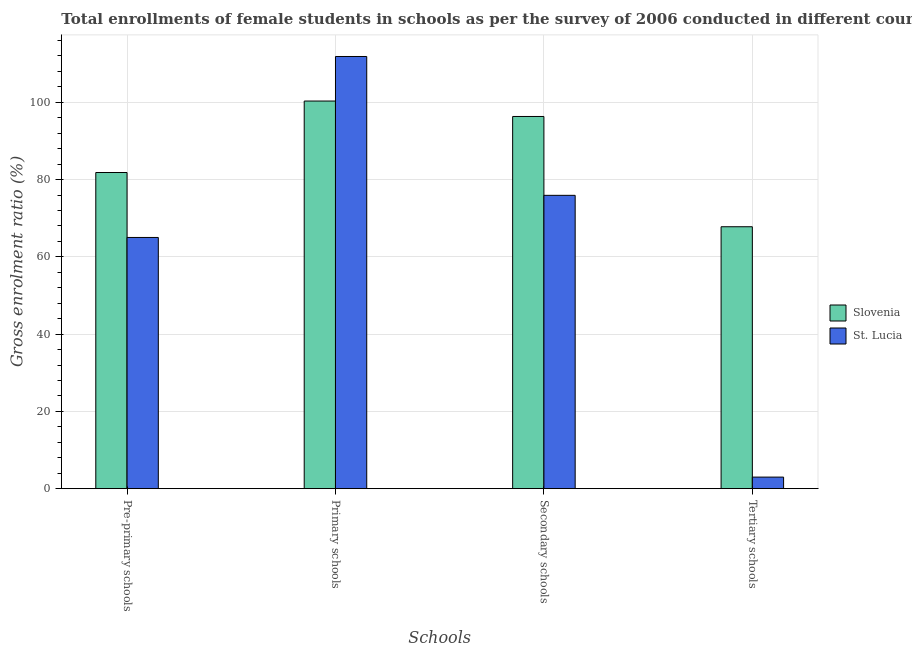How many different coloured bars are there?
Provide a succinct answer. 2. What is the label of the 4th group of bars from the left?
Keep it short and to the point. Tertiary schools. What is the gross enrolment ratio(female) in primary schools in St. Lucia?
Provide a succinct answer. 111.87. Across all countries, what is the maximum gross enrolment ratio(female) in tertiary schools?
Offer a terse response. 67.8. Across all countries, what is the minimum gross enrolment ratio(female) in secondary schools?
Your answer should be compact. 75.93. In which country was the gross enrolment ratio(female) in tertiary schools maximum?
Provide a short and direct response. Slovenia. In which country was the gross enrolment ratio(female) in tertiary schools minimum?
Provide a short and direct response. St. Lucia. What is the total gross enrolment ratio(female) in secondary schools in the graph?
Keep it short and to the point. 172.28. What is the difference between the gross enrolment ratio(female) in tertiary schools in Slovenia and that in St. Lucia?
Keep it short and to the point. 64.8. What is the difference between the gross enrolment ratio(female) in secondary schools in Slovenia and the gross enrolment ratio(female) in pre-primary schools in St. Lucia?
Offer a terse response. 31.32. What is the average gross enrolment ratio(female) in secondary schools per country?
Ensure brevity in your answer.  86.14. What is the difference between the gross enrolment ratio(female) in pre-primary schools and gross enrolment ratio(female) in primary schools in St. Lucia?
Give a very brief answer. -46.85. In how many countries, is the gross enrolment ratio(female) in tertiary schools greater than 48 %?
Your response must be concise. 1. What is the ratio of the gross enrolment ratio(female) in pre-primary schools in Slovenia to that in St. Lucia?
Offer a terse response. 1.26. Is the gross enrolment ratio(female) in tertiary schools in Slovenia less than that in St. Lucia?
Give a very brief answer. No. What is the difference between the highest and the second highest gross enrolment ratio(female) in primary schools?
Offer a very short reply. 11.53. What is the difference between the highest and the lowest gross enrolment ratio(female) in pre-primary schools?
Offer a very short reply. 16.82. Is the sum of the gross enrolment ratio(female) in secondary schools in St. Lucia and Slovenia greater than the maximum gross enrolment ratio(female) in primary schools across all countries?
Your answer should be very brief. Yes. Is it the case that in every country, the sum of the gross enrolment ratio(female) in pre-primary schools and gross enrolment ratio(female) in secondary schools is greater than the sum of gross enrolment ratio(female) in primary schools and gross enrolment ratio(female) in tertiary schools?
Give a very brief answer. Yes. What does the 2nd bar from the left in Primary schools represents?
Ensure brevity in your answer.  St. Lucia. What does the 1st bar from the right in Tertiary schools represents?
Your answer should be very brief. St. Lucia. Is it the case that in every country, the sum of the gross enrolment ratio(female) in pre-primary schools and gross enrolment ratio(female) in primary schools is greater than the gross enrolment ratio(female) in secondary schools?
Ensure brevity in your answer.  Yes. How many countries are there in the graph?
Make the answer very short. 2. Does the graph contain any zero values?
Offer a very short reply. No. Does the graph contain grids?
Provide a short and direct response. Yes. Where does the legend appear in the graph?
Your response must be concise. Center right. What is the title of the graph?
Provide a succinct answer. Total enrollments of female students in schools as per the survey of 2006 conducted in different countries. Does "Serbia" appear as one of the legend labels in the graph?
Keep it short and to the point. No. What is the label or title of the X-axis?
Your response must be concise. Schools. What is the label or title of the Y-axis?
Give a very brief answer. Gross enrolment ratio (%). What is the Gross enrolment ratio (%) of Slovenia in Pre-primary schools?
Provide a short and direct response. 81.84. What is the Gross enrolment ratio (%) of St. Lucia in Pre-primary schools?
Offer a terse response. 65.03. What is the Gross enrolment ratio (%) of Slovenia in Primary schools?
Your answer should be very brief. 100.34. What is the Gross enrolment ratio (%) in St. Lucia in Primary schools?
Keep it short and to the point. 111.87. What is the Gross enrolment ratio (%) of Slovenia in Secondary schools?
Provide a succinct answer. 96.35. What is the Gross enrolment ratio (%) in St. Lucia in Secondary schools?
Provide a succinct answer. 75.93. What is the Gross enrolment ratio (%) in Slovenia in Tertiary schools?
Give a very brief answer. 67.8. What is the Gross enrolment ratio (%) in St. Lucia in Tertiary schools?
Provide a short and direct response. 3. Across all Schools, what is the maximum Gross enrolment ratio (%) of Slovenia?
Give a very brief answer. 100.34. Across all Schools, what is the maximum Gross enrolment ratio (%) of St. Lucia?
Offer a very short reply. 111.87. Across all Schools, what is the minimum Gross enrolment ratio (%) in Slovenia?
Offer a terse response. 67.8. Across all Schools, what is the minimum Gross enrolment ratio (%) of St. Lucia?
Your answer should be compact. 3. What is the total Gross enrolment ratio (%) in Slovenia in the graph?
Keep it short and to the point. 346.33. What is the total Gross enrolment ratio (%) in St. Lucia in the graph?
Provide a short and direct response. 255.83. What is the difference between the Gross enrolment ratio (%) of Slovenia in Pre-primary schools and that in Primary schools?
Make the answer very short. -18.5. What is the difference between the Gross enrolment ratio (%) in St. Lucia in Pre-primary schools and that in Primary schools?
Offer a terse response. -46.85. What is the difference between the Gross enrolment ratio (%) in Slovenia in Pre-primary schools and that in Secondary schools?
Your response must be concise. -14.51. What is the difference between the Gross enrolment ratio (%) in St. Lucia in Pre-primary schools and that in Secondary schools?
Give a very brief answer. -10.9. What is the difference between the Gross enrolment ratio (%) in Slovenia in Pre-primary schools and that in Tertiary schools?
Make the answer very short. 14.04. What is the difference between the Gross enrolment ratio (%) in St. Lucia in Pre-primary schools and that in Tertiary schools?
Offer a very short reply. 62.03. What is the difference between the Gross enrolment ratio (%) in Slovenia in Primary schools and that in Secondary schools?
Make the answer very short. 4. What is the difference between the Gross enrolment ratio (%) in St. Lucia in Primary schools and that in Secondary schools?
Make the answer very short. 35.94. What is the difference between the Gross enrolment ratio (%) of Slovenia in Primary schools and that in Tertiary schools?
Offer a terse response. 32.54. What is the difference between the Gross enrolment ratio (%) of St. Lucia in Primary schools and that in Tertiary schools?
Provide a short and direct response. 108.88. What is the difference between the Gross enrolment ratio (%) of Slovenia in Secondary schools and that in Tertiary schools?
Ensure brevity in your answer.  28.55. What is the difference between the Gross enrolment ratio (%) of St. Lucia in Secondary schools and that in Tertiary schools?
Give a very brief answer. 72.93. What is the difference between the Gross enrolment ratio (%) in Slovenia in Pre-primary schools and the Gross enrolment ratio (%) in St. Lucia in Primary schools?
Provide a short and direct response. -30.03. What is the difference between the Gross enrolment ratio (%) in Slovenia in Pre-primary schools and the Gross enrolment ratio (%) in St. Lucia in Secondary schools?
Your response must be concise. 5.91. What is the difference between the Gross enrolment ratio (%) of Slovenia in Pre-primary schools and the Gross enrolment ratio (%) of St. Lucia in Tertiary schools?
Provide a short and direct response. 78.84. What is the difference between the Gross enrolment ratio (%) of Slovenia in Primary schools and the Gross enrolment ratio (%) of St. Lucia in Secondary schools?
Give a very brief answer. 24.41. What is the difference between the Gross enrolment ratio (%) in Slovenia in Primary schools and the Gross enrolment ratio (%) in St. Lucia in Tertiary schools?
Give a very brief answer. 97.35. What is the difference between the Gross enrolment ratio (%) in Slovenia in Secondary schools and the Gross enrolment ratio (%) in St. Lucia in Tertiary schools?
Ensure brevity in your answer.  93.35. What is the average Gross enrolment ratio (%) in Slovenia per Schools?
Keep it short and to the point. 86.58. What is the average Gross enrolment ratio (%) in St. Lucia per Schools?
Provide a succinct answer. 63.96. What is the difference between the Gross enrolment ratio (%) of Slovenia and Gross enrolment ratio (%) of St. Lucia in Pre-primary schools?
Provide a succinct answer. 16.82. What is the difference between the Gross enrolment ratio (%) of Slovenia and Gross enrolment ratio (%) of St. Lucia in Primary schools?
Your answer should be compact. -11.53. What is the difference between the Gross enrolment ratio (%) of Slovenia and Gross enrolment ratio (%) of St. Lucia in Secondary schools?
Your response must be concise. 20.42. What is the difference between the Gross enrolment ratio (%) of Slovenia and Gross enrolment ratio (%) of St. Lucia in Tertiary schools?
Your response must be concise. 64.8. What is the ratio of the Gross enrolment ratio (%) of Slovenia in Pre-primary schools to that in Primary schools?
Provide a succinct answer. 0.82. What is the ratio of the Gross enrolment ratio (%) of St. Lucia in Pre-primary schools to that in Primary schools?
Your response must be concise. 0.58. What is the ratio of the Gross enrolment ratio (%) of Slovenia in Pre-primary schools to that in Secondary schools?
Offer a very short reply. 0.85. What is the ratio of the Gross enrolment ratio (%) of St. Lucia in Pre-primary schools to that in Secondary schools?
Keep it short and to the point. 0.86. What is the ratio of the Gross enrolment ratio (%) of Slovenia in Pre-primary schools to that in Tertiary schools?
Provide a short and direct response. 1.21. What is the ratio of the Gross enrolment ratio (%) in St. Lucia in Pre-primary schools to that in Tertiary schools?
Offer a very short reply. 21.7. What is the ratio of the Gross enrolment ratio (%) in Slovenia in Primary schools to that in Secondary schools?
Provide a short and direct response. 1.04. What is the ratio of the Gross enrolment ratio (%) of St. Lucia in Primary schools to that in Secondary schools?
Offer a very short reply. 1.47. What is the ratio of the Gross enrolment ratio (%) of Slovenia in Primary schools to that in Tertiary schools?
Ensure brevity in your answer.  1.48. What is the ratio of the Gross enrolment ratio (%) of St. Lucia in Primary schools to that in Tertiary schools?
Keep it short and to the point. 37.33. What is the ratio of the Gross enrolment ratio (%) in Slovenia in Secondary schools to that in Tertiary schools?
Make the answer very short. 1.42. What is the ratio of the Gross enrolment ratio (%) in St. Lucia in Secondary schools to that in Tertiary schools?
Your response must be concise. 25.34. What is the difference between the highest and the second highest Gross enrolment ratio (%) in Slovenia?
Keep it short and to the point. 4. What is the difference between the highest and the second highest Gross enrolment ratio (%) in St. Lucia?
Your response must be concise. 35.94. What is the difference between the highest and the lowest Gross enrolment ratio (%) in Slovenia?
Keep it short and to the point. 32.54. What is the difference between the highest and the lowest Gross enrolment ratio (%) of St. Lucia?
Give a very brief answer. 108.88. 